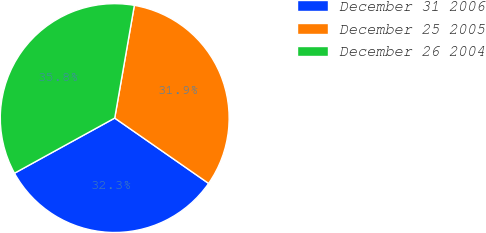Convert chart. <chart><loc_0><loc_0><loc_500><loc_500><pie_chart><fcel>December 31 2006<fcel>December 25 2005<fcel>December 26 2004<nl><fcel>32.32%<fcel>31.93%<fcel>35.75%<nl></chart> 